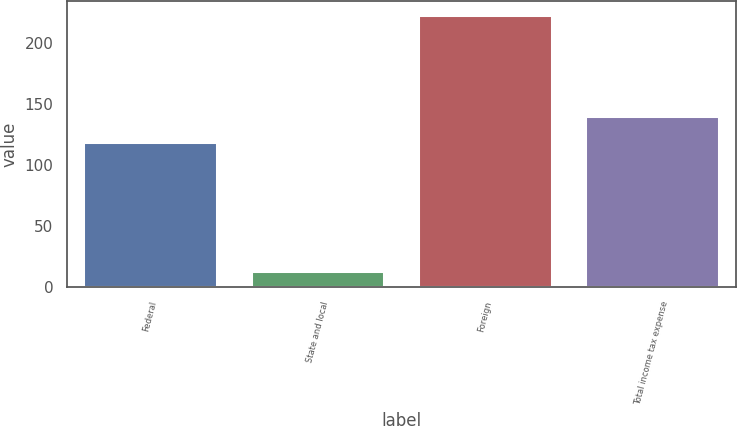Convert chart to OTSL. <chart><loc_0><loc_0><loc_500><loc_500><bar_chart><fcel>Federal<fcel>State and local<fcel>Foreign<fcel>Total income tax expense<nl><fcel>119<fcel>13<fcel>223<fcel>140<nl></chart> 